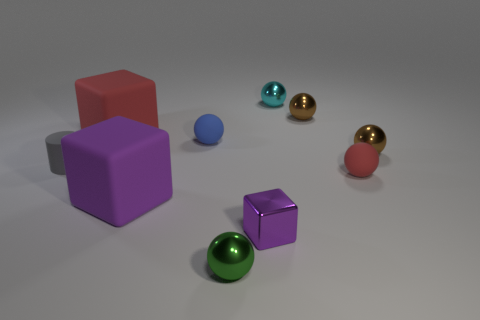How many other objects are there of the same color as the rubber cylinder?
Give a very brief answer. 0. There is a purple object that is on the left side of the purple metal object; is it the same size as the red sphere?
Offer a very short reply. No. There is a large purple object; what number of tiny blue matte spheres are behind it?
Ensure brevity in your answer.  1. Are there any brown objects that have the same size as the gray thing?
Offer a very short reply. Yes. Do the tiny cylinder and the shiny cube have the same color?
Make the answer very short. No. There is a large object that is behind the tiny rubber ball that is on the right side of the small blue rubber sphere; what color is it?
Make the answer very short. Red. What number of matte things are both in front of the blue thing and behind the purple matte object?
Give a very brief answer. 2. How many other metallic things have the same shape as the large purple object?
Your answer should be compact. 1. Do the blue sphere and the tiny purple block have the same material?
Your response must be concise. No. There is a red object that is right of the large purple rubber object that is to the left of the metal cube; what shape is it?
Give a very brief answer. Sphere. 